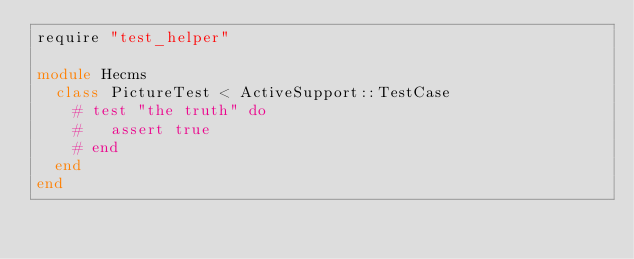<code> <loc_0><loc_0><loc_500><loc_500><_Ruby_>require "test_helper"

module Hecms
  class PictureTest < ActiveSupport::TestCase
    # test "the truth" do
    #   assert true
    # end
  end
end
</code> 